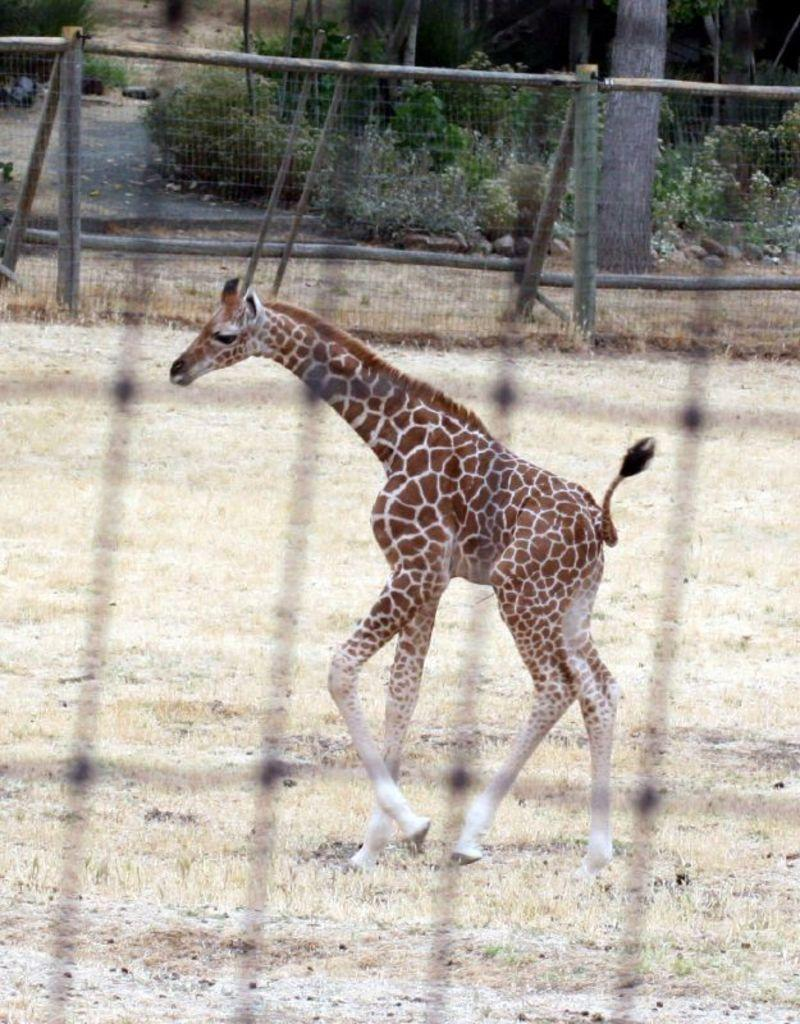What animal is located in the middle of the image? There is a giraffe in the middle of the image. What is the purpose of the structure visible in the image? The image contains a fence, which is likely used to enclose or separate areas. What type of vegetation can be seen in the background of the image? There are plants and trees in the background of the image. What type of lift can be seen in the image? There is no lift present in the image. How many bubbles are floating around the giraffe in the image? There are no bubbles present in the image. 